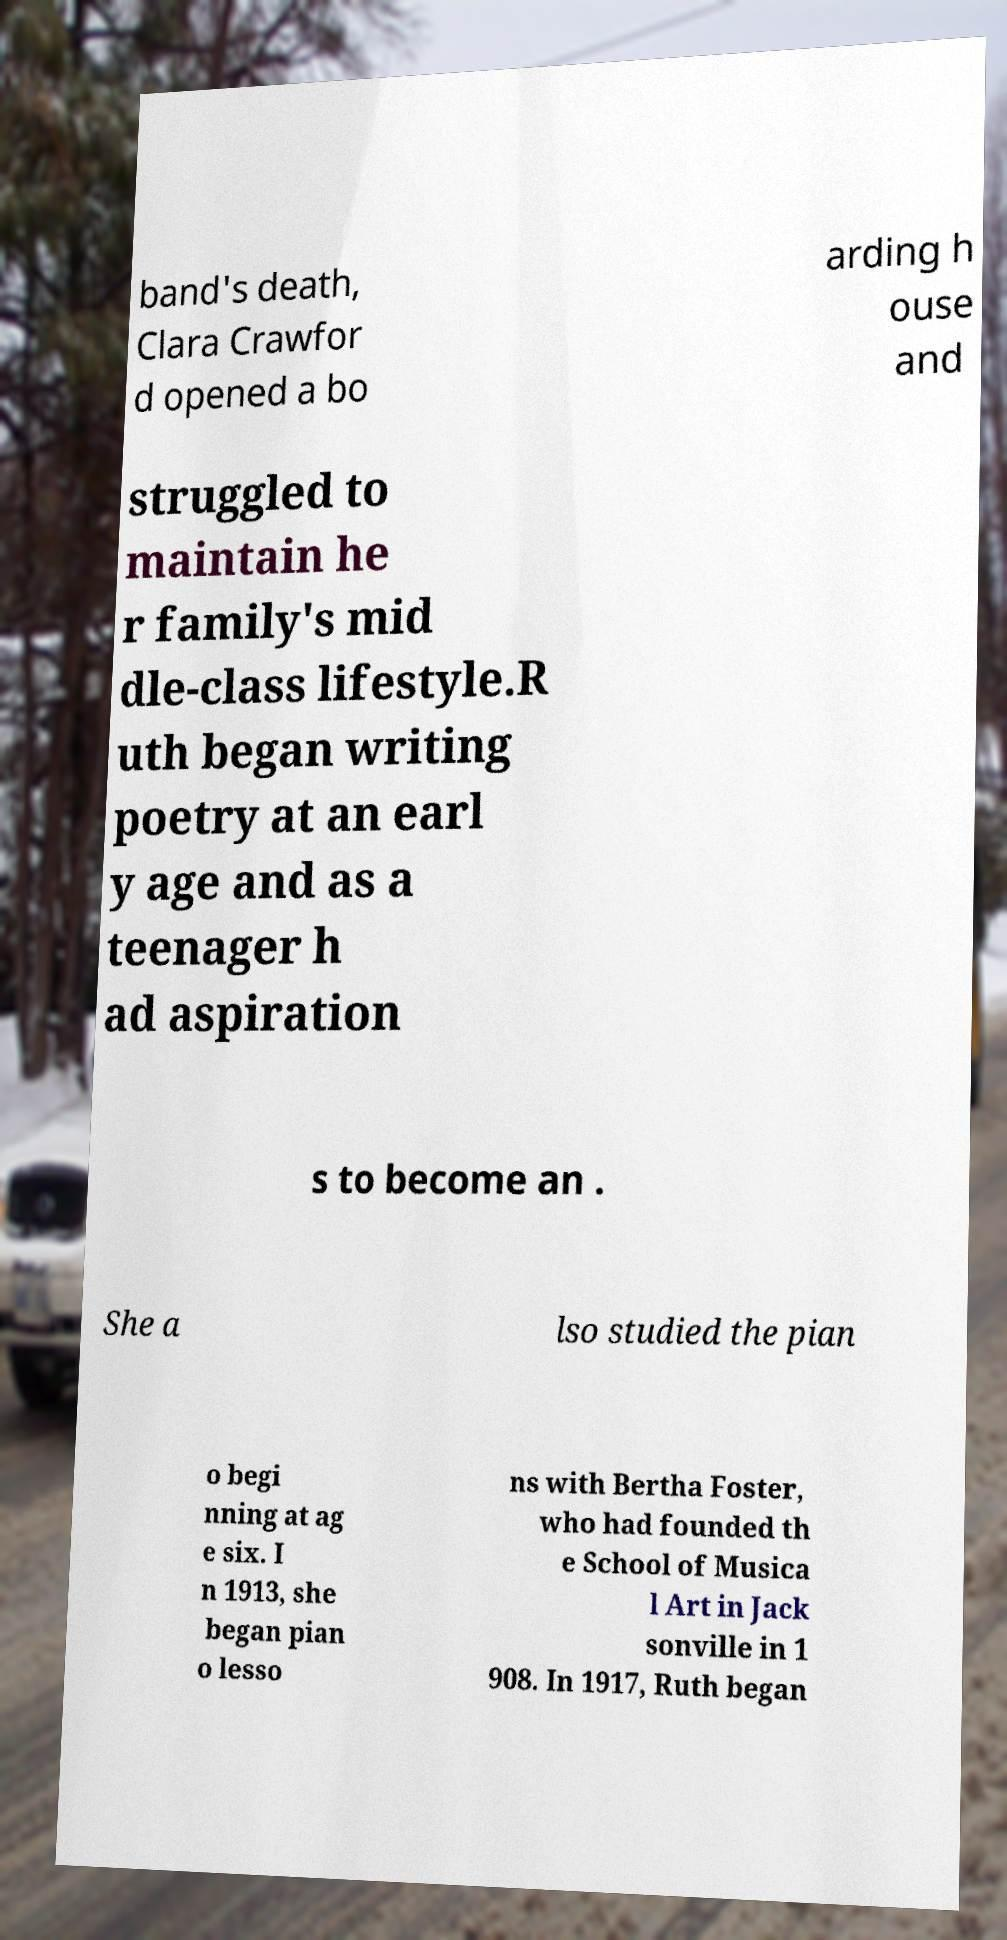Please identify and transcribe the text found in this image. band's death, Clara Crawfor d opened a bo arding h ouse and struggled to maintain he r family's mid dle-class lifestyle.R uth began writing poetry at an earl y age and as a teenager h ad aspiration s to become an . She a lso studied the pian o begi nning at ag e six. I n 1913, she began pian o lesso ns with Bertha Foster, who had founded th e School of Musica l Art in Jack sonville in 1 908. In 1917, Ruth began 